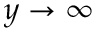Convert formula to latex. <formula><loc_0><loc_0><loc_500><loc_500>y \rightarrow \infty</formula> 